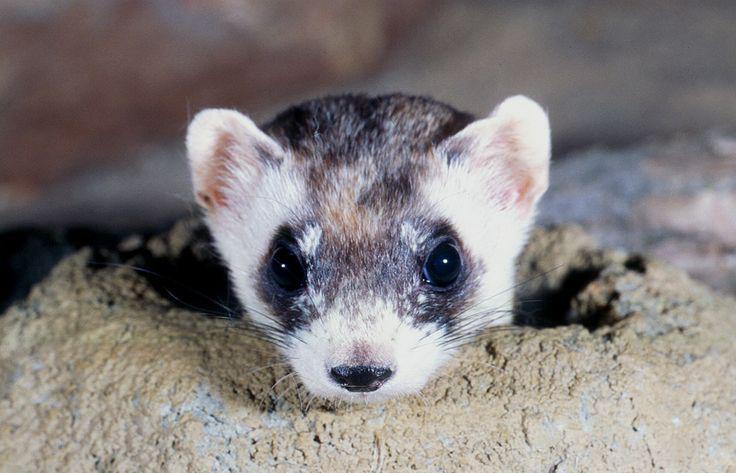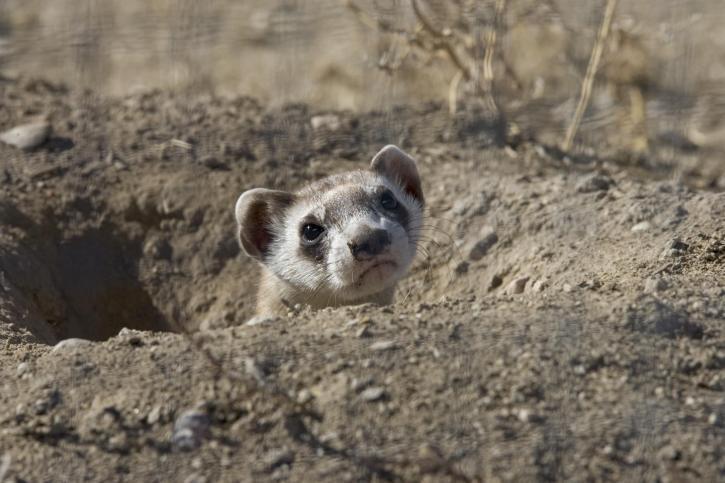The first image is the image on the left, the second image is the image on the right. Evaluate the accuracy of this statement regarding the images: "The right image contains a ferret sticking their head out of a dirt hole.". Is it true? Answer yes or no. Yes. The first image is the image on the left, the second image is the image on the right. Evaluate the accuracy of this statement regarding the images: "Each image shows a single ferret with its head emerging from a hole in the dirt.". Is it true? Answer yes or no. Yes. 